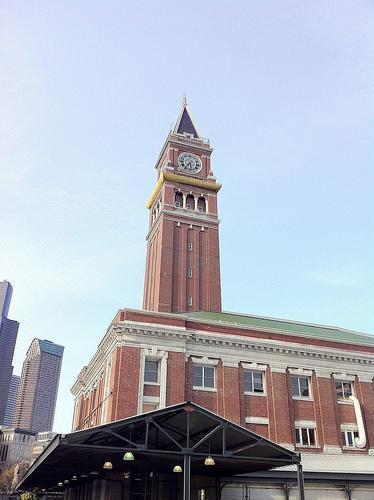How many clock?
Give a very brief answer. 1. 